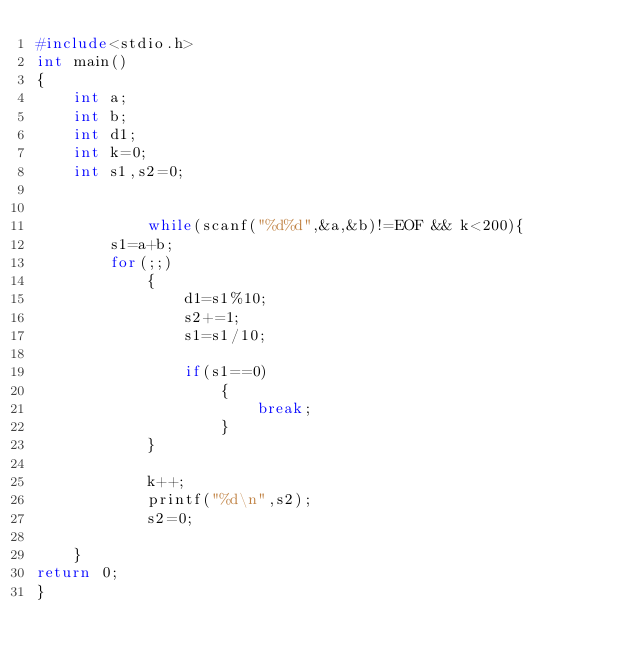<code> <loc_0><loc_0><loc_500><loc_500><_C_>#include<stdio.h>
int main()
{
    int a;
    int b;
    int d1;
    int k=0;
    int s1,s2=0;

    
            while(scanf("%d%d",&a,&b)!=EOF && k<200){
        s1=a+b;
        for(;;)
            {
                d1=s1%10;
                s2+=1;
                s1=s1/10;

                if(s1==0)
                    {
                        break;
                    }
            }

            k++;
            printf("%d\n",s2);
            s2=0;

    }
return 0;
}</code> 